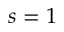Convert formula to latex. <formula><loc_0><loc_0><loc_500><loc_500>s = 1</formula> 